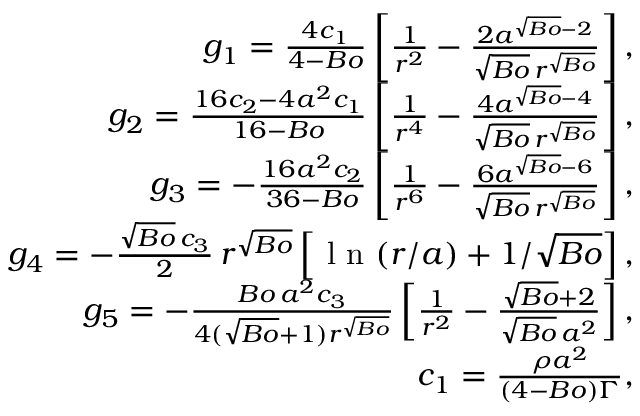Convert formula to latex. <formula><loc_0><loc_0><loc_500><loc_500>\begin{array} { r } { g _ { 1 } = \frac { 4 c _ { 1 } } { 4 - B o } \left [ \frac { 1 } { r ^ { 2 } } - \frac { 2 a ^ { \sqrt { B o } - 2 } } { \sqrt { B o } \, r ^ { \sqrt { B o } } } \right ] , } \\ { g _ { 2 } = \frac { 1 6 c _ { 2 } - 4 a ^ { 2 } c _ { 1 } } { 1 6 - B o } \left [ \frac { 1 } { r ^ { 4 } } - \frac { 4 a ^ { \sqrt { B o } - 4 } } { \sqrt { B o } \, r ^ { \sqrt { B o } } } \right ] , } \\ { g _ { 3 } = - \frac { 1 6 a ^ { 2 } c _ { 2 } } { 3 6 - B o } \left [ \frac { 1 } { r ^ { 6 } } - \frac { 6 a ^ { \sqrt { B o } - 6 } } { \sqrt { B o } \, r ^ { \sqrt { B o } } } \right ] , } \\ { g _ { 4 } = - \frac { \sqrt { B o } \, c _ { 3 } } { 2 } \, r ^ { \sqrt { B o } } \left [ \ln ( r / a ) + 1 / \sqrt { B o } \right ] , } \\ { g _ { 5 } = - \frac { B o \, a ^ { 2 } c _ { 3 } } { 4 ( \sqrt { B o } + 1 ) r ^ { \sqrt { B o } } } \left [ \frac { 1 } { r ^ { 2 } } - \frac { \sqrt { B o } + 2 } { \sqrt { B o } \, a ^ { 2 } } \right ] , } \\ { c _ { 1 } = \frac { \rho { a } ^ { 2 } } { ( 4 - B o ) \Gamma } , } \end{array}</formula> 